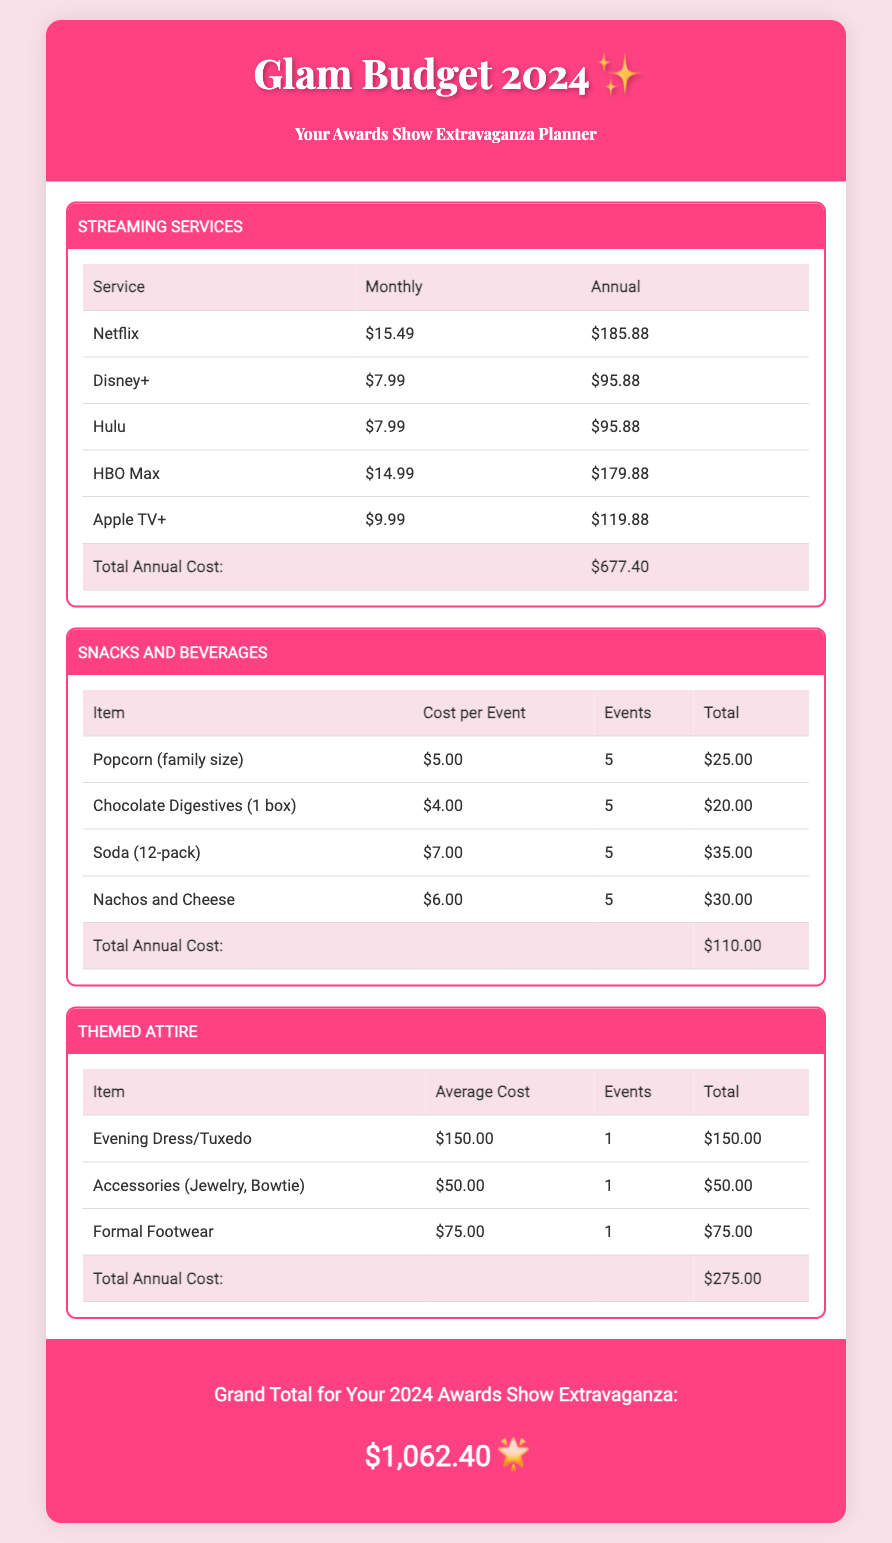what is the total annual cost for streaming services? The total annual cost for streaming services is mentioned in the document under the Streaming Services category.
Answer: $677.40 what is the cost per event for nachos and cheese? The cost per event for nachos and cheese is provided in the Snacks and Beverages section.
Answer: $6.00 how many events are planned for snacks? The document specifies the number of events planned for snacks in the Snacks and Beverages category.
Answer: 5 what is the total annual cost for snacks and beverages? The total annual cost for snacks and beverages can be found in the Snacks and Beverages section.
Answer: $110.00 what is the average cost of an evening dress or tuxedo? The average cost of an evening dress or tuxedo is listed in the Themed Attire category.
Answer: $150.00 what is the grand total for the 2024 awards show extravaganza? The grand total is mentioned at the end of the document, summarizing all costs.
Answer: $1,062.40 how much is spent on accessories like jewelry and bowtie? The document states the cost for accessories in the Themed Attire section.
Answer: $50.00 what is the total annual cost for themed attire? The total annual cost for themed attire is displayed in the Themed Attire category.
Answer: $275.00 how many streaming services are listed in the document? The document provides a list of streaming services in the Streaming Services category.
Answer: 5 